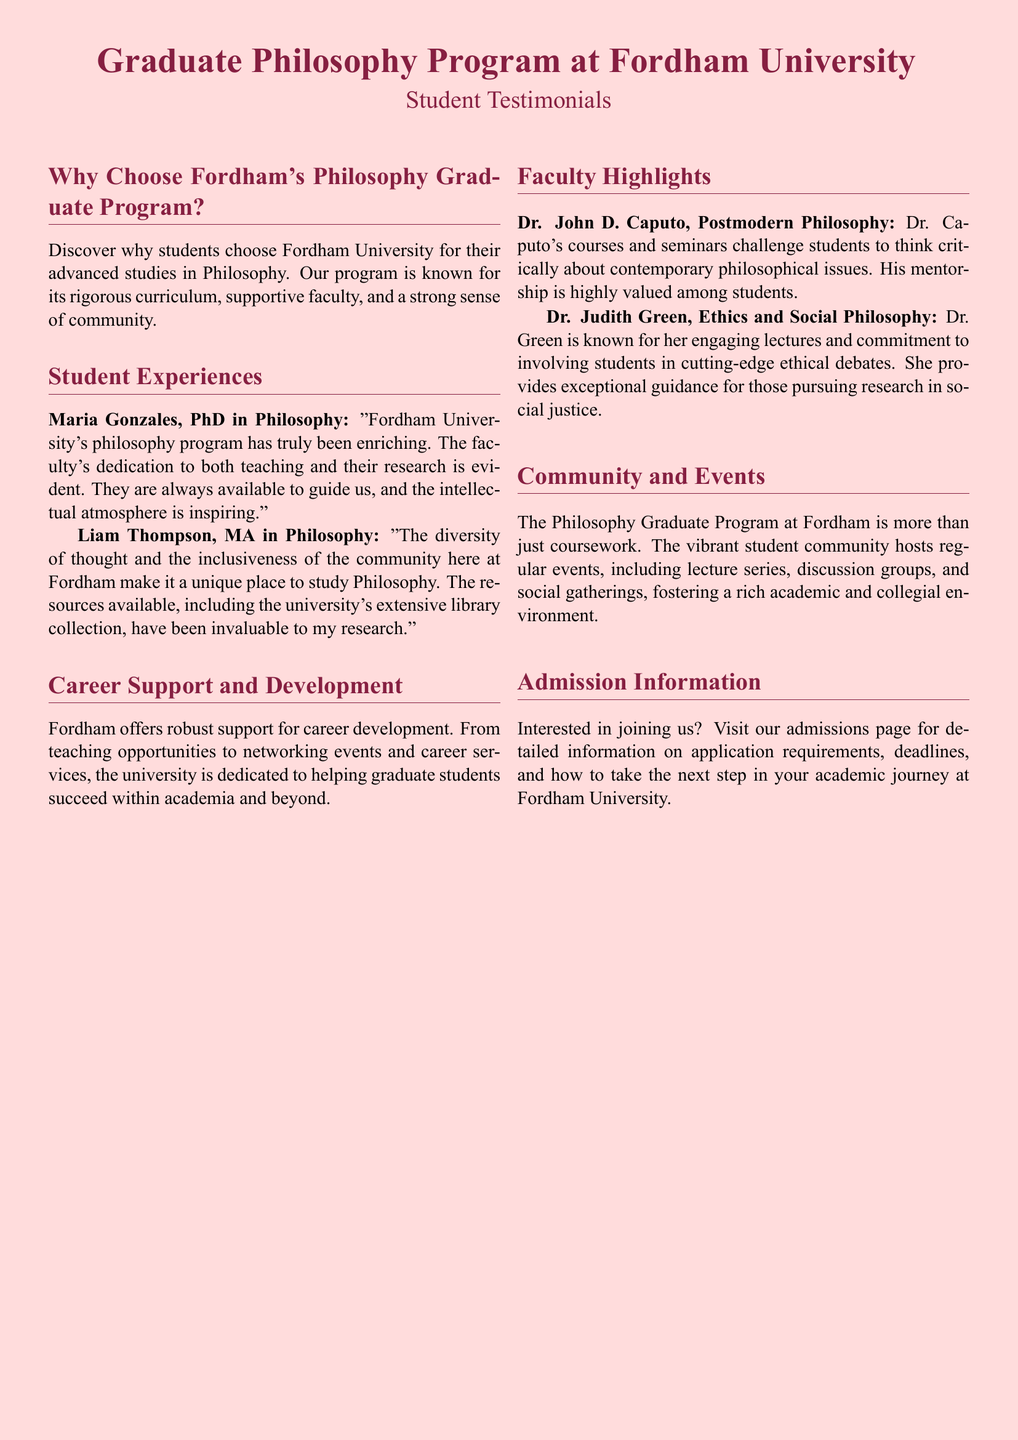What is the name of a PhD graduate from Fordham's Philosophy program? The document mentions Maria Gonzales as a PhD graduate, who provided a testimonial about the program.
Answer: Maria Gonzales Who is known for teaching Ethics and Social Philosophy? According to the document, Dr. Judith Green is characterized as teaching Ethics and Social Philosophy.
Answer: Dr. Judith Green What kind of support does Fordham offer for career development? The document states that Fordham provides robust support for career development, including teaching opportunities and networking events.
Answer: Career development support What key feature of the philosophy program does Liam Thompson highlight? Liam Thompson notes the diversity of thought and inclusiveness as unique aspects of the philosophy community at Fordham.
Answer: Diversity and inclusiveness What type of community events does the Philosophy Graduate Program host? The document mentions that the program hosts lecture series, discussion groups, and social gatherings as events to foster community.
Answer: Lecture series, discussion groups, and social gatherings Which faculty member's mentorship is highly valued among students? Dr. John D. Caputo is mentioned as a faculty member whose mentorship is highly valued.
Answer: Dr. John D. Caputo What color is the document page background? The page background color of the document is described as light maroon.
Answer: Light maroon How many students provided testimonials in the document? The document includes testimonials from two students, Maria Gonzales and Liam Thompson.
Answer: Two students 